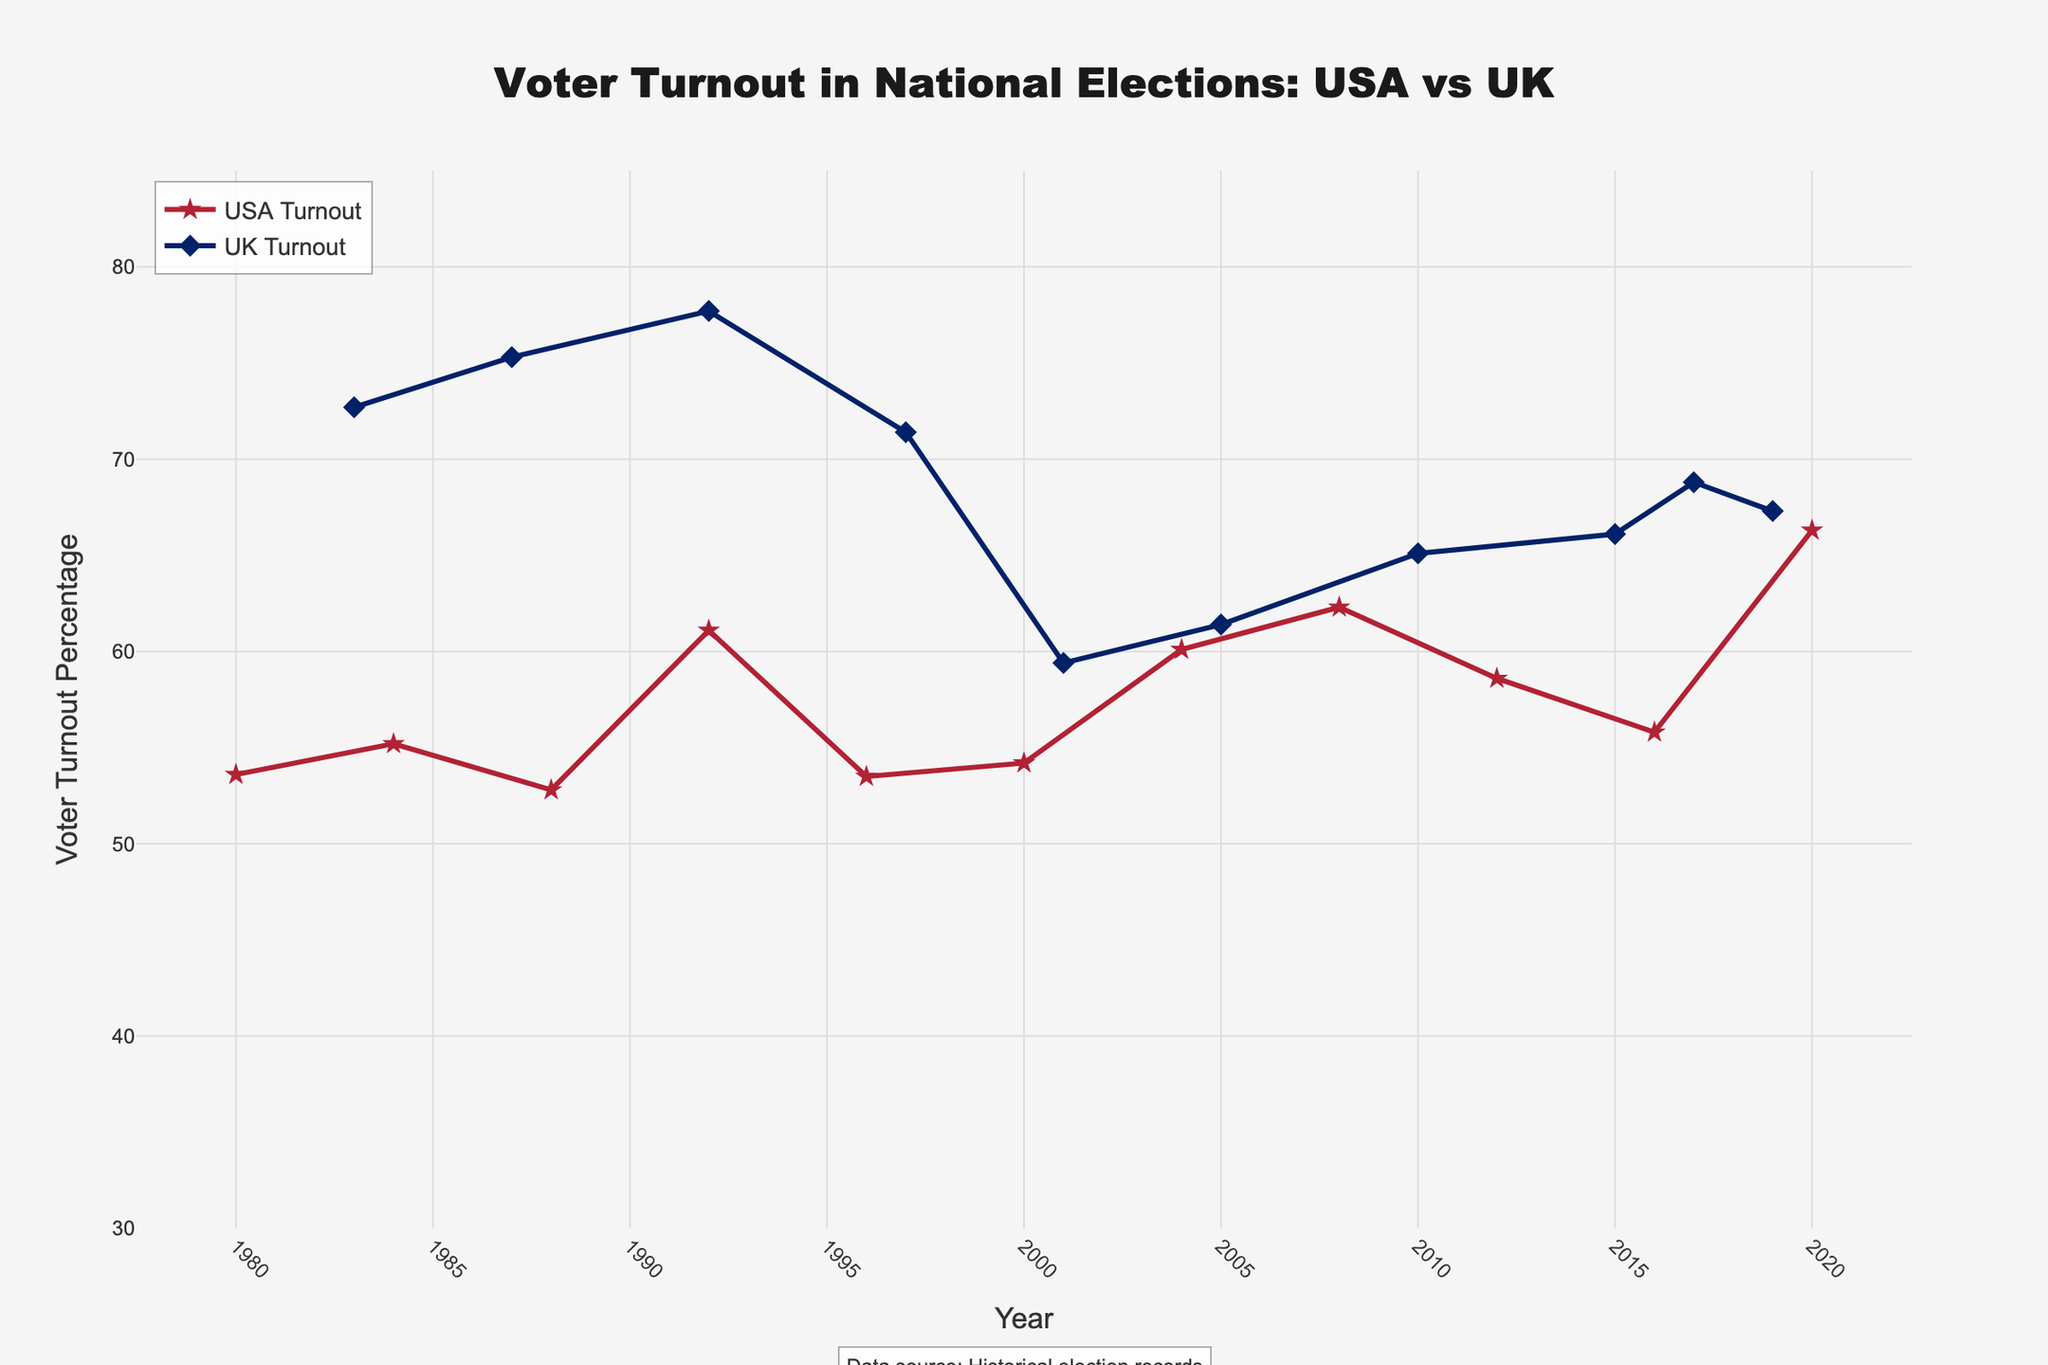What is the title of the plot? The title is located at the top of the figure in larger and bold font. It helps to understand the subject of the visualized data.
Answer: Voter Turnout in National Elections: USA vs UK How many years are represented in the data for the USA? Count the distinct data points along the x-axis that correspond to the USA.
Answer: 10 Which country had a higher voter turnout percentage in the year 1992? To determine this, locate the voter turnout percentages for both the USA and UK for the year 1992 and compare them. The USA is at 61.1%, while the UK is at 77.7%.
Answer: UK What is the voter turnout percentage trend for the UK between 2001 and 2010? Identify the data points for the years 2001, 2005, and 2010 for the UK, then observe the direction of the trend.
Answer: Increasing What is the lowest voter turnout percentage for the UK, and in which year did it occur? Identify the minimum y-value for the UK data points and note the corresponding year on the x-axis. The lowest point appears to be in 2001 at 59.4%.
Answer: 59.4% in 2001 How did the voter turnout percentage for the USA change from 1980 to 2020? Compare the voter turnout percentage in 1980 (53.6%) and 2020 (66.3%) by observing the start and end points on the USA data line.
Answer: Increased What was the voter turnout percentage for the USA during the 2008 election? Locate the data point corresponding to the year 2008 on the USA data line. The percentage is 62.3%.
Answer: 62.3% When did the UK's voter turnout percentage first drop below 70%? Scan the data points for the UK until you find the first point where the percentage falls below 70%. This occurred in 1997.
Answer: 1997 Compare the voter turnout percentage trends between the USA and UK from 1980 to 2020. Examine the lines for both countries from 1980 to 2020. The USA shows fluctuations with an overall upward trend, while the UK shows a general slight downward trend with fluctuations.
Answer: USA upward trend, UK slight downward trend Between 2015 and 2017, did voter turnout increase or decrease more sharply for the UK? Observe the slope of the line between the data points for 2015 and 2017 for the UK on the y-axis. The slope appears to be positive and represents an increase in voter turnout.
Answer: Increase 